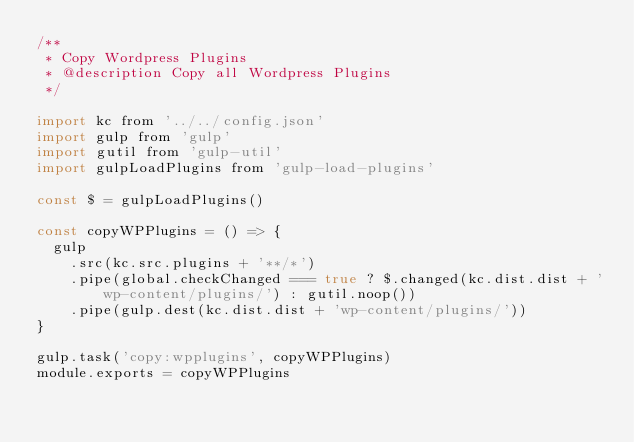<code> <loc_0><loc_0><loc_500><loc_500><_JavaScript_>/**
 * Copy Wordpress Plugins
 * @description Copy all Wordpress Plugins
 */

import kc from '../../config.json'
import gulp from 'gulp'
import gutil from 'gulp-util'
import gulpLoadPlugins from 'gulp-load-plugins'

const $ = gulpLoadPlugins()

const copyWPPlugins = () => {
  gulp
    .src(kc.src.plugins + '**/*')
    .pipe(global.checkChanged === true ? $.changed(kc.dist.dist + 'wp-content/plugins/') : gutil.noop())
    .pipe(gulp.dest(kc.dist.dist + 'wp-content/plugins/'))
}

gulp.task('copy:wpplugins', copyWPPlugins)
module.exports = copyWPPlugins
</code> 